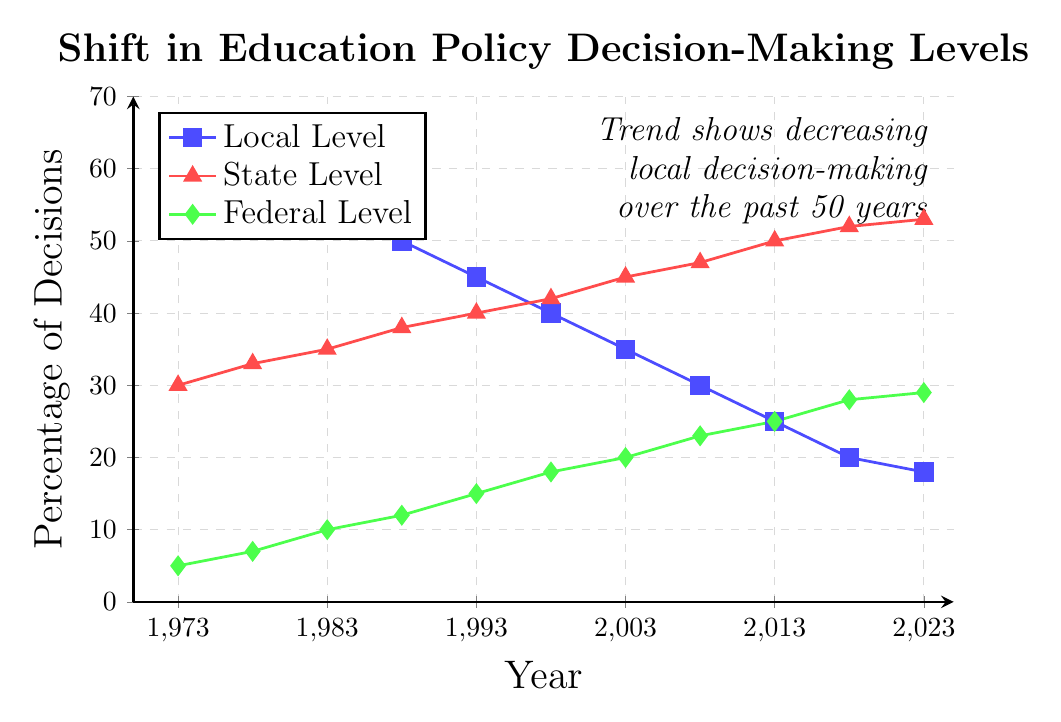What is the percentage difference in decisions made at the local level between the years 1973 and 2023? Subtract the percentage of local level decisions in 2023 from the percentage in 1973: 65% - 18% = 47%.
Answer: 47% Which decision-making level had the highest percentage in 1993? Compare the percentages for local, state, and federal levels in 1993. Local: 45%, State: 40%, Federal: 15%. The local level had the highest percentage.
Answer: Local Level How did the percentage of federal level decisions change between 1983 and 2018? Subtract the percentage of federal level decisions in 1983 from the percentage in 2018: 28% - 10% = 18%.
Answer: Increased by 18% In which year did the state level decisions first surpass 45%? Look for the year when the percentage of state level decisions exceeds 45% for the first time. It happens in 2003, when it is at 45%.
Answer: 2003 By how much did the percentage of state level decisions increase from 1973 to 2013? Subtract the percentage of state level decisions in 1973 from the percentage in 2013: 50% - 30% = 20%.
Answer: 20% What visual cue indicates the trend of decreasing local decision-making over the last 50 years? The blue line representing the local level has a downward slope over the entire period from 1973 to 2023. Additionally, there is a textual annotation on the top-right corner of the plot indicating this trend.
Answer: Downward slope of the blue line and textual annotation Can you determine the overall trend for federal level decisions from 1973 to 2023? The green line representing federal level decisions shows an upward trend, increasing steadily from 5% in 1973 to 29% in 2023.
Answer: Upward trend Calculate the average percentage of decisions made at the state level from 1973 to 2023. Sum the percentages of state level decisions for each year and divide by the number of years:
(30% + 33% + 35% + 38% + 40% + 42% + 45% + 47% + 50% + 52% + 53%) / 11 = 43%.
Answer: 43% Which level showed the greatest percentage increase from 1973 to 2023? By calculating the percentage increase:
Local: 65% to 18%, decrease of 47%.
State: 30% to 53%, increase of 23%.
Federal: 5% to 29%, increase of 24%.
The federal level showed the greatest percentage increase.
Answer: Federal Level 